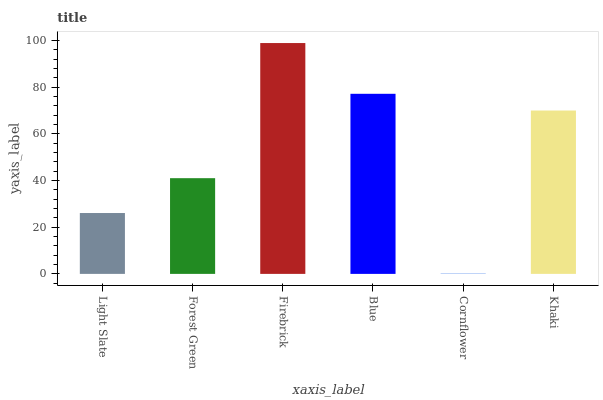Is Forest Green the minimum?
Answer yes or no. No. Is Forest Green the maximum?
Answer yes or no. No. Is Forest Green greater than Light Slate?
Answer yes or no. Yes. Is Light Slate less than Forest Green?
Answer yes or no. Yes. Is Light Slate greater than Forest Green?
Answer yes or no. No. Is Forest Green less than Light Slate?
Answer yes or no. No. Is Khaki the high median?
Answer yes or no. Yes. Is Forest Green the low median?
Answer yes or no. Yes. Is Firebrick the high median?
Answer yes or no. No. Is Light Slate the low median?
Answer yes or no. No. 